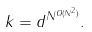Convert formula to latex. <formula><loc_0><loc_0><loc_500><loc_500>k = d ^ { N ^ { O ( N ^ { 2 } ) } } .</formula> 